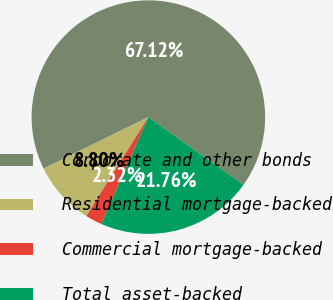Convert chart to OTSL. <chart><loc_0><loc_0><loc_500><loc_500><pie_chart><fcel>Corporate and other bonds<fcel>Residential mortgage-backed<fcel>Commercial mortgage-backed<fcel>Total asset-backed<nl><fcel>67.12%<fcel>8.8%<fcel>2.32%<fcel>21.76%<nl></chart> 